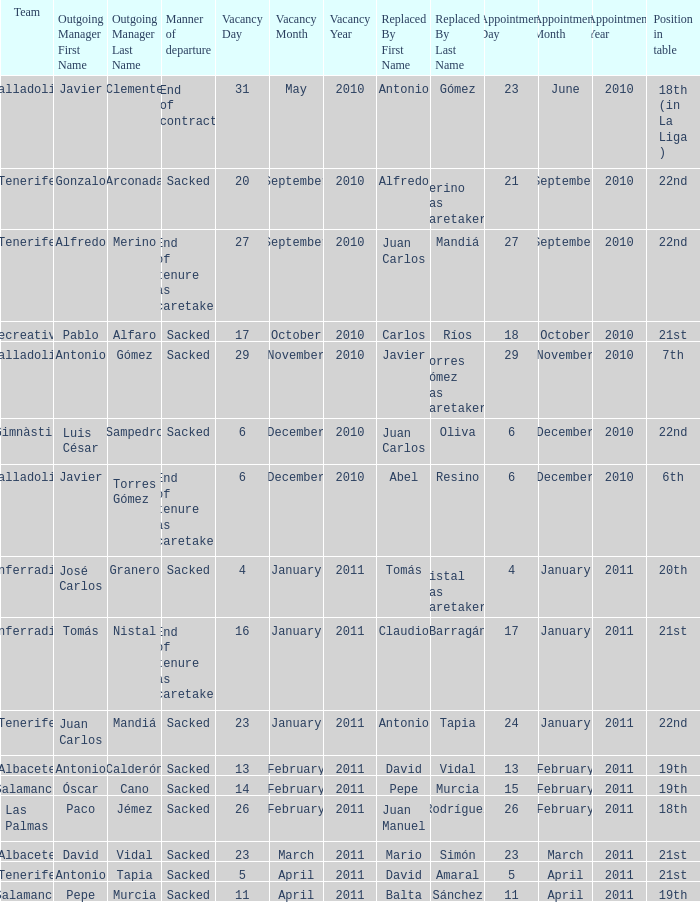What was the position of appointment date 17 january 2011 21st. 